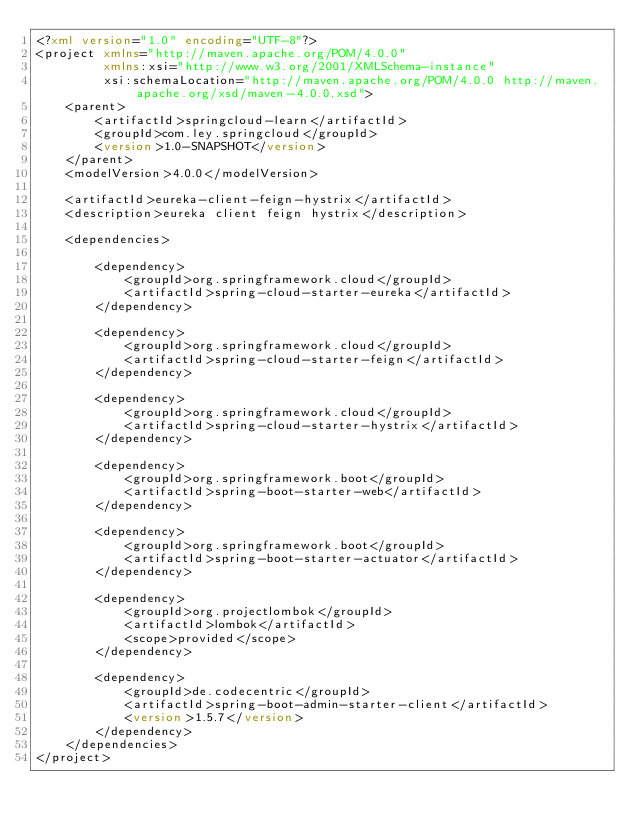<code> <loc_0><loc_0><loc_500><loc_500><_XML_><?xml version="1.0" encoding="UTF-8"?>
<project xmlns="http://maven.apache.org/POM/4.0.0"
         xmlns:xsi="http://www.w3.org/2001/XMLSchema-instance"
         xsi:schemaLocation="http://maven.apache.org/POM/4.0.0 http://maven.apache.org/xsd/maven-4.0.0.xsd">
    <parent>
        <artifactId>springcloud-learn</artifactId>
        <groupId>com.ley.springcloud</groupId>
        <version>1.0-SNAPSHOT</version>
    </parent>
    <modelVersion>4.0.0</modelVersion>

    <artifactId>eureka-client-feign-hystrix</artifactId>
    <description>eureka client feign hystrix</description>

    <dependencies>

        <dependency>
            <groupId>org.springframework.cloud</groupId>
            <artifactId>spring-cloud-starter-eureka</artifactId>
        </dependency>

        <dependency>
            <groupId>org.springframework.cloud</groupId>
            <artifactId>spring-cloud-starter-feign</artifactId>
        </dependency>

        <dependency>
            <groupId>org.springframework.cloud</groupId>
            <artifactId>spring-cloud-starter-hystrix</artifactId>
        </dependency>

        <dependency>
            <groupId>org.springframework.boot</groupId>
            <artifactId>spring-boot-starter-web</artifactId>
        </dependency>

        <dependency>
            <groupId>org.springframework.boot</groupId>
            <artifactId>spring-boot-starter-actuator</artifactId>
        </dependency>

        <dependency>
            <groupId>org.projectlombok</groupId>
            <artifactId>lombok</artifactId>
            <scope>provided</scope>
        </dependency>

        <dependency>
            <groupId>de.codecentric</groupId>
            <artifactId>spring-boot-admin-starter-client</artifactId>
            <version>1.5.7</version>
        </dependency>
    </dependencies>
</project></code> 